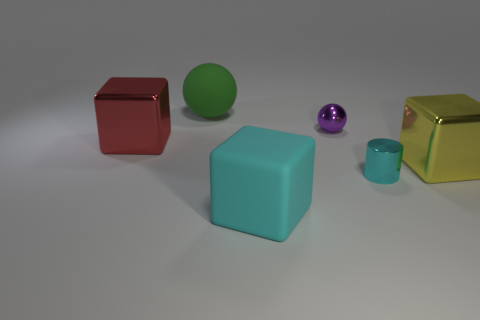The big cube to the right of the cyan thing that is right of the small metal sphere is made of what material?
Give a very brief answer. Metal. How many rubber blocks are the same color as the small shiny cylinder?
Provide a short and direct response. 1. What is the shape of the red object that is the same material as the cyan cylinder?
Make the answer very short. Cube. What is the size of the matte thing that is in front of the red metal cube?
Your response must be concise. Large. Is the number of large cyan blocks that are behind the small metal cylinder the same as the number of tiny cyan metal cylinders that are on the right side of the shiny sphere?
Offer a very short reply. No. What color is the big metal object that is on the right side of the large metal object that is left of the metallic thing that is in front of the yellow metallic block?
Make the answer very short. Yellow. What number of cyan objects are to the left of the small purple thing and behind the cyan matte cube?
Offer a very short reply. 0. There is a metallic sphere that is on the left side of the tiny cyan metallic cylinder; is it the same color as the big metal block that is behind the large yellow metal object?
Make the answer very short. No. Are there any other things that are made of the same material as the large yellow thing?
Your answer should be compact. Yes. There is another object that is the same shape as the small purple shiny object; what is its size?
Your answer should be very brief. Large. 